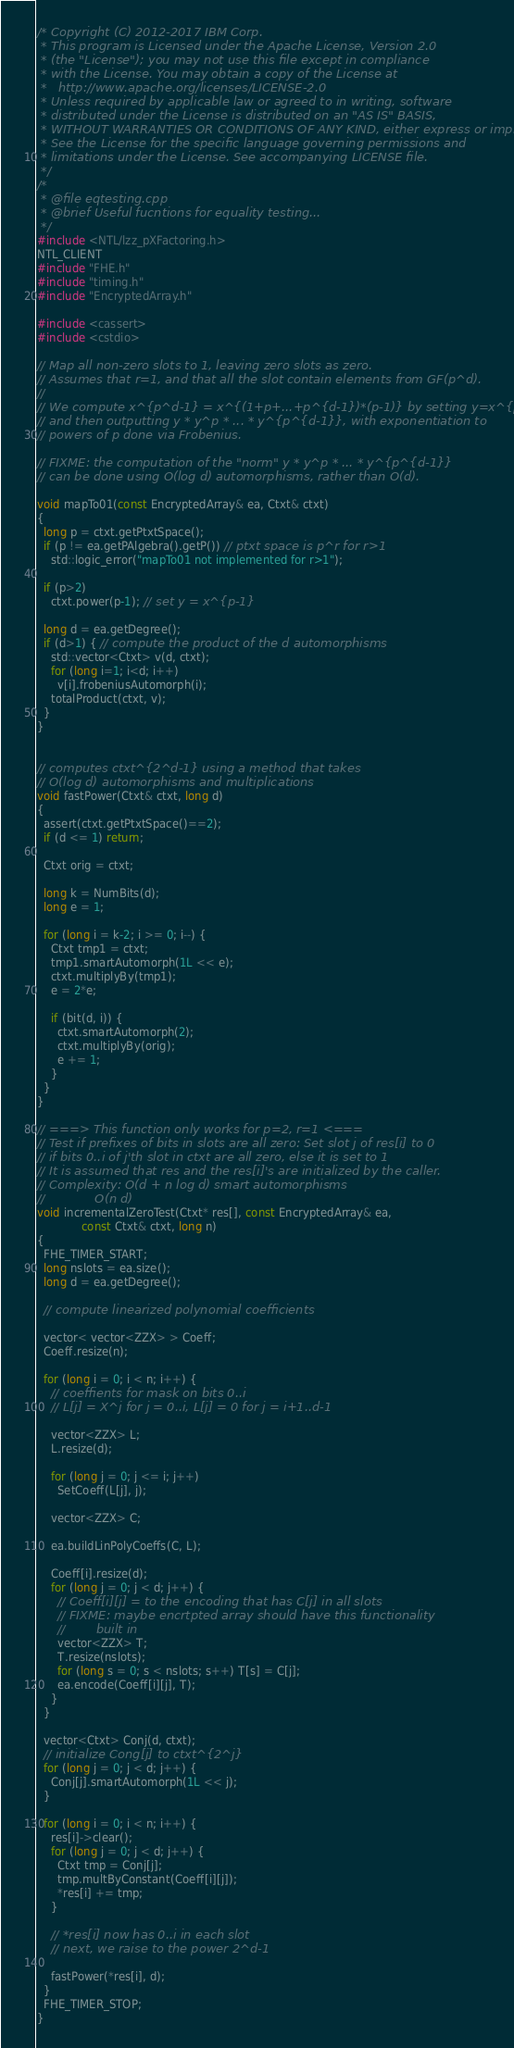Convert code to text. <code><loc_0><loc_0><loc_500><loc_500><_C++_>/* Copyright (C) 2012-2017 IBM Corp.
 * This program is Licensed under the Apache License, Version 2.0
 * (the "License"); you may not use this file except in compliance
 * with the License. You may obtain a copy of the License at
 *   http://www.apache.org/licenses/LICENSE-2.0
 * Unless required by applicable law or agreed to in writing, software
 * distributed under the License is distributed on an "AS IS" BASIS,
 * WITHOUT WARRANTIES OR CONDITIONS OF ANY KIND, either express or implied.
 * See the License for the specific language governing permissions and
 * limitations under the License. See accompanying LICENSE file.
 */
/*
 * @file eqtesting.cpp
 * @brief Useful fucntions for equality testing...
 */
#include <NTL/lzz_pXFactoring.h>
NTL_CLIENT
#include "FHE.h"
#include "timing.h"
#include "EncryptedArray.h"

#include <cassert>
#include <cstdio>

// Map all non-zero slots to 1, leaving zero slots as zero.
// Assumes that r=1, and that all the slot contain elements from GF(p^d).
//
// We compute x^{p^d-1} = x^{(1+p+...+p^{d-1})*(p-1)} by setting y=x^{p-1}
// and then outputting y * y^p * ... * y^{p^{d-1}}, with exponentiation to
// powers of p done via Frobenius.

// FIXME: the computation of the "norm" y * y^p * ... * y^{p^{d-1}}
// can be done using O(log d) automorphisms, rather than O(d).

void mapTo01(const EncryptedArray& ea, Ctxt& ctxt)
{
  long p = ctxt.getPtxtSpace();
  if (p != ea.getPAlgebra().getP()) // ptxt space is p^r for r>1
    std::logic_error("mapTo01 not implemented for r>1");

  if (p>2)
    ctxt.power(p-1); // set y = x^{p-1}

  long d = ea.getDegree();
  if (d>1) { // compute the product of the d automorphisms
    std::vector<Ctxt> v(d, ctxt);
    for (long i=1; i<d; i++)
      v[i].frobeniusAutomorph(i);
    totalProduct(ctxt, v);
  }
}


// computes ctxt^{2^d-1} using a method that takes
// O(log d) automorphisms and multiplications
void fastPower(Ctxt& ctxt, long d) 
{
  assert(ctxt.getPtxtSpace()==2);
  if (d <= 1) return;

  Ctxt orig = ctxt;

  long k = NumBits(d);
  long e = 1;

  for (long i = k-2; i >= 0; i--) {
    Ctxt tmp1 = ctxt;
    tmp1.smartAutomorph(1L << e);
    ctxt.multiplyBy(tmp1);
    e = 2*e;

    if (bit(d, i)) {
      ctxt.smartAutomorph(2);
      ctxt.multiplyBy(orig);
      e += 1;
    }
  }
}

// ===> This function only works for p=2, r=1 <===
// Test if prefixes of bits in slots are all zero: Set slot j of res[i] to 0
// if bits 0..i of j'th slot in ctxt are all zero, else it is set to 1
// It is assumed that res and the res[i]'s are initialized by the caller.
// Complexity: O(d + n log d) smart automorphisms
//             O(n d) 
void incrementalZeroTest(Ctxt* res[], const EncryptedArray& ea,
			 const Ctxt& ctxt, long n)
{
  FHE_TIMER_START;
  long nslots = ea.size();
  long d = ea.getDegree();

  // compute linearized polynomial coefficients

  vector< vector<ZZX> > Coeff;
  Coeff.resize(n);

  for (long i = 0; i < n; i++) {
    // coeffients for mask on bits 0..i
    // L[j] = X^j for j = 0..i, L[j] = 0 for j = i+1..d-1

    vector<ZZX> L;
    L.resize(d);

    for (long j = 0; j <= i; j++) 
      SetCoeff(L[j], j);

    vector<ZZX> C;

    ea.buildLinPolyCoeffs(C, L);

    Coeff[i].resize(d);
    for (long j = 0; j < d; j++) {
      // Coeff[i][j] = to the encoding that has C[j] in all slots
      // FIXME: maybe encrtpted array should have this functionality
      //        built in
      vector<ZZX> T;
      T.resize(nslots);
      for (long s = 0; s < nslots; s++) T[s] = C[j];
      ea.encode(Coeff[i][j], T);
    }
  }

  vector<Ctxt> Conj(d, ctxt);
  // initialize Cong[j] to ctxt^{2^j}
  for (long j = 0; j < d; j++) {
    Conj[j].smartAutomorph(1L << j);
  }

  for (long i = 0; i < n; i++) {
    res[i]->clear();
    for (long j = 0; j < d; j++) {
      Ctxt tmp = Conj[j];
      tmp.multByConstant(Coeff[i][j]);
      *res[i] += tmp;
    }

    // *res[i] now has 0..i in each slot
    // next, we raise to the power 2^d-1

    fastPower(*res[i], d);
  }
  FHE_TIMER_STOP;
}
</code> 